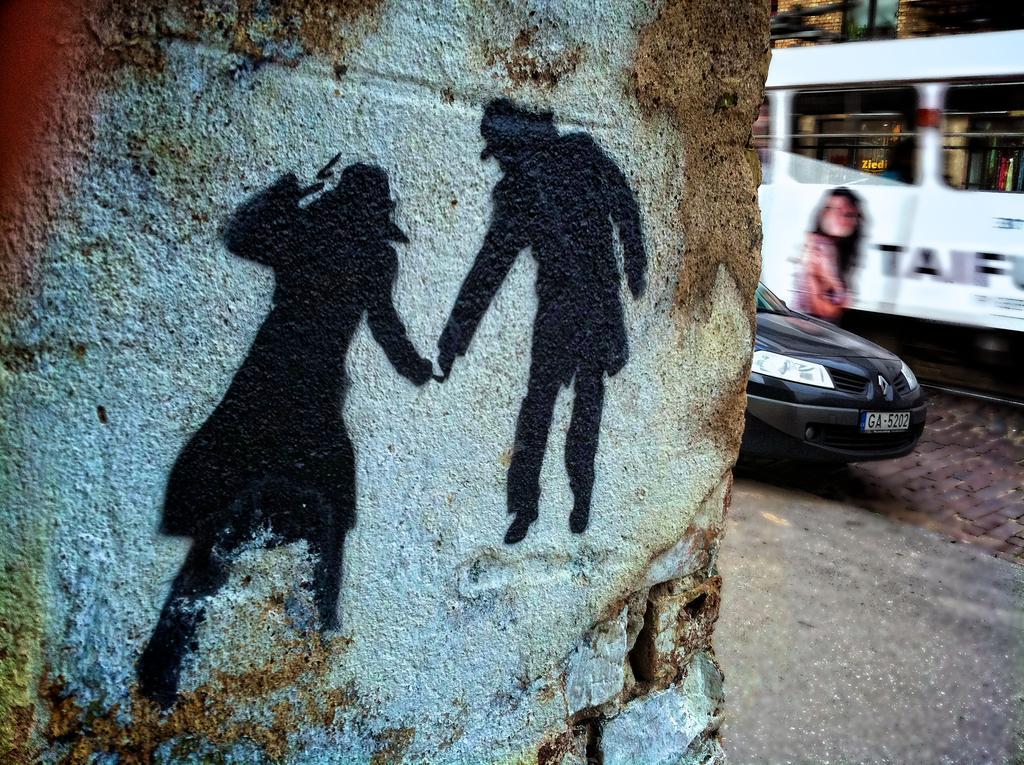In one or two sentences, can you explain what this image depicts? In this image, we can see shadows on the wall and in the background, there are vehicles. At the bottom, there is road. 